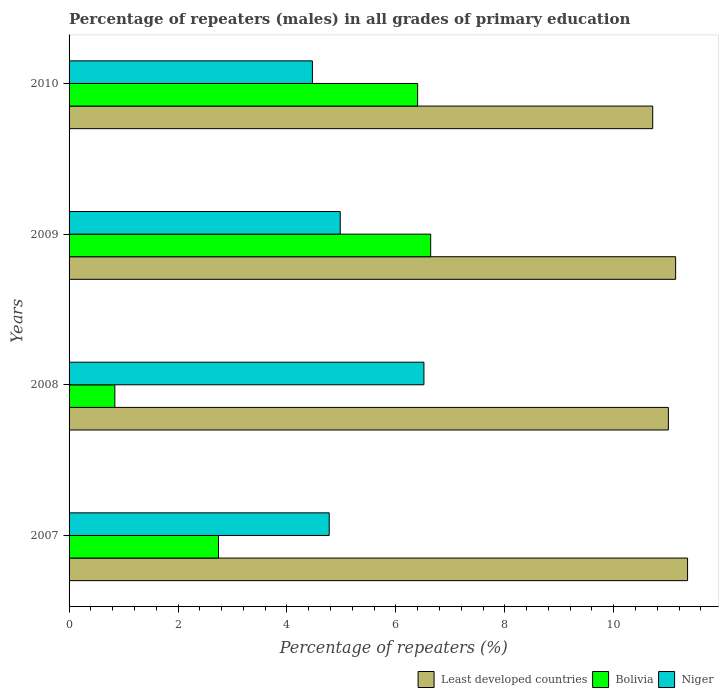How many different coloured bars are there?
Give a very brief answer. 3. How many groups of bars are there?
Provide a short and direct response. 4. How many bars are there on the 4th tick from the bottom?
Offer a very short reply. 3. What is the label of the 2nd group of bars from the top?
Provide a short and direct response. 2009. In how many cases, is the number of bars for a given year not equal to the number of legend labels?
Your answer should be very brief. 0. What is the percentage of repeaters (males) in Bolivia in 2008?
Your answer should be very brief. 0.84. Across all years, what is the maximum percentage of repeaters (males) in Niger?
Provide a short and direct response. 6.51. Across all years, what is the minimum percentage of repeaters (males) in Least developed countries?
Provide a short and direct response. 10.72. In which year was the percentage of repeaters (males) in Bolivia maximum?
Provide a short and direct response. 2009. In which year was the percentage of repeaters (males) in Bolivia minimum?
Your response must be concise. 2008. What is the total percentage of repeaters (males) in Least developed countries in the graph?
Offer a terse response. 44.21. What is the difference between the percentage of repeaters (males) in Bolivia in 2009 and that in 2010?
Offer a very short reply. 0.24. What is the difference between the percentage of repeaters (males) in Bolivia in 2010 and the percentage of repeaters (males) in Least developed countries in 2009?
Give a very brief answer. -4.74. What is the average percentage of repeaters (males) in Bolivia per year?
Give a very brief answer. 4.16. In the year 2010, what is the difference between the percentage of repeaters (males) in Least developed countries and percentage of repeaters (males) in Niger?
Offer a terse response. 6.25. What is the ratio of the percentage of repeaters (males) in Least developed countries in 2007 to that in 2008?
Your answer should be very brief. 1.03. Is the difference between the percentage of repeaters (males) in Least developed countries in 2009 and 2010 greater than the difference between the percentage of repeaters (males) in Niger in 2009 and 2010?
Keep it short and to the point. No. What is the difference between the highest and the second highest percentage of repeaters (males) in Bolivia?
Keep it short and to the point. 0.24. What is the difference between the highest and the lowest percentage of repeaters (males) in Least developed countries?
Offer a very short reply. 0.64. In how many years, is the percentage of repeaters (males) in Niger greater than the average percentage of repeaters (males) in Niger taken over all years?
Offer a terse response. 1. What does the 1st bar from the top in 2010 represents?
Your answer should be compact. Niger. What does the 1st bar from the bottom in 2007 represents?
Your response must be concise. Least developed countries. Is it the case that in every year, the sum of the percentage of repeaters (males) in Niger and percentage of repeaters (males) in Least developed countries is greater than the percentage of repeaters (males) in Bolivia?
Give a very brief answer. Yes. Are all the bars in the graph horizontal?
Provide a succinct answer. Yes. What is the difference between two consecutive major ticks on the X-axis?
Provide a succinct answer. 2. Where does the legend appear in the graph?
Your answer should be very brief. Bottom right. What is the title of the graph?
Keep it short and to the point. Percentage of repeaters (males) in all grades of primary education. Does "Middle East & North Africa (developing only)" appear as one of the legend labels in the graph?
Offer a very short reply. No. What is the label or title of the X-axis?
Make the answer very short. Percentage of repeaters (%). What is the label or title of the Y-axis?
Give a very brief answer. Years. What is the Percentage of repeaters (%) of Least developed countries in 2007?
Provide a short and direct response. 11.36. What is the Percentage of repeaters (%) in Bolivia in 2007?
Provide a succinct answer. 2.74. What is the Percentage of repeaters (%) in Niger in 2007?
Ensure brevity in your answer.  4.78. What is the Percentage of repeaters (%) in Least developed countries in 2008?
Give a very brief answer. 11. What is the Percentage of repeaters (%) in Bolivia in 2008?
Your answer should be compact. 0.84. What is the Percentage of repeaters (%) in Niger in 2008?
Keep it short and to the point. 6.51. What is the Percentage of repeaters (%) of Least developed countries in 2009?
Provide a succinct answer. 11.14. What is the Percentage of repeaters (%) of Bolivia in 2009?
Offer a terse response. 6.64. What is the Percentage of repeaters (%) in Niger in 2009?
Your answer should be very brief. 4.98. What is the Percentage of repeaters (%) in Least developed countries in 2010?
Your answer should be compact. 10.72. What is the Percentage of repeaters (%) in Bolivia in 2010?
Your response must be concise. 6.4. What is the Percentage of repeaters (%) in Niger in 2010?
Keep it short and to the point. 4.47. Across all years, what is the maximum Percentage of repeaters (%) of Least developed countries?
Your answer should be very brief. 11.36. Across all years, what is the maximum Percentage of repeaters (%) in Bolivia?
Your response must be concise. 6.64. Across all years, what is the maximum Percentage of repeaters (%) of Niger?
Keep it short and to the point. 6.51. Across all years, what is the minimum Percentage of repeaters (%) in Least developed countries?
Keep it short and to the point. 10.72. Across all years, what is the minimum Percentage of repeaters (%) in Bolivia?
Your answer should be very brief. 0.84. Across all years, what is the minimum Percentage of repeaters (%) of Niger?
Provide a succinct answer. 4.47. What is the total Percentage of repeaters (%) in Least developed countries in the graph?
Make the answer very short. 44.21. What is the total Percentage of repeaters (%) in Bolivia in the graph?
Offer a very short reply. 16.62. What is the total Percentage of repeaters (%) in Niger in the graph?
Your answer should be compact. 20.74. What is the difference between the Percentage of repeaters (%) in Least developed countries in 2007 and that in 2008?
Give a very brief answer. 0.35. What is the difference between the Percentage of repeaters (%) in Bolivia in 2007 and that in 2008?
Provide a short and direct response. 1.9. What is the difference between the Percentage of repeaters (%) in Niger in 2007 and that in 2008?
Keep it short and to the point. -1.74. What is the difference between the Percentage of repeaters (%) in Least developed countries in 2007 and that in 2009?
Make the answer very short. 0.22. What is the difference between the Percentage of repeaters (%) of Bolivia in 2007 and that in 2009?
Provide a short and direct response. -3.9. What is the difference between the Percentage of repeaters (%) of Niger in 2007 and that in 2009?
Give a very brief answer. -0.2. What is the difference between the Percentage of repeaters (%) in Least developed countries in 2007 and that in 2010?
Your answer should be compact. 0.64. What is the difference between the Percentage of repeaters (%) in Bolivia in 2007 and that in 2010?
Your response must be concise. -3.66. What is the difference between the Percentage of repeaters (%) of Niger in 2007 and that in 2010?
Ensure brevity in your answer.  0.31. What is the difference between the Percentage of repeaters (%) of Least developed countries in 2008 and that in 2009?
Provide a succinct answer. -0.13. What is the difference between the Percentage of repeaters (%) in Bolivia in 2008 and that in 2009?
Keep it short and to the point. -5.8. What is the difference between the Percentage of repeaters (%) of Niger in 2008 and that in 2009?
Make the answer very short. 1.54. What is the difference between the Percentage of repeaters (%) of Least developed countries in 2008 and that in 2010?
Make the answer very short. 0.29. What is the difference between the Percentage of repeaters (%) in Bolivia in 2008 and that in 2010?
Offer a very short reply. -5.56. What is the difference between the Percentage of repeaters (%) of Niger in 2008 and that in 2010?
Ensure brevity in your answer.  2.05. What is the difference between the Percentage of repeaters (%) in Least developed countries in 2009 and that in 2010?
Make the answer very short. 0.42. What is the difference between the Percentage of repeaters (%) in Bolivia in 2009 and that in 2010?
Make the answer very short. 0.24. What is the difference between the Percentage of repeaters (%) of Niger in 2009 and that in 2010?
Provide a short and direct response. 0.51. What is the difference between the Percentage of repeaters (%) in Least developed countries in 2007 and the Percentage of repeaters (%) in Bolivia in 2008?
Keep it short and to the point. 10.51. What is the difference between the Percentage of repeaters (%) of Least developed countries in 2007 and the Percentage of repeaters (%) of Niger in 2008?
Your answer should be compact. 4.84. What is the difference between the Percentage of repeaters (%) in Bolivia in 2007 and the Percentage of repeaters (%) in Niger in 2008?
Ensure brevity in your answer.  -3.77. What is the difference between the Percentage of repeaters (%) of Least developed countries in 2007 and the Percentage of repeaters (%) of Bolivia in 2009?
Make the answer very short. 4.72. What is the difference between the Percentage of repeaters (%) in Least developed countries in 2007 and the Percentage of repeaters (%) in Niger in 2009?
Ensure brevity in your answer.  6.38. What is the difference between the Percentage of repeaters (%) of Bolivia in 2007 and the Percentage of repeaters (%) of Niger in 2009?
Provide a succinct answer. -2.23. What is the difference between the Percentage of repeaters (%) in Least developed countries in 2007 and the Percentage of repeaters (%) in Bolivia in 2010?
Offer a very short reply. 4.96. What is the difference between the Percentage of repeaters (%) of Least developed countries in 2007 and the Percentage of repeaters (%) of Niger in 2010?
Make the answer very short. 6.89. What is the difference between the Percentage of repeaters (%) in Bolivia in 2007 and the Percentage of repeaters (%) in Niger in 2010?
Provide a succinct answer. -1.72. What is the difference between the Percentage of repeaters (%) of Least developed countries in 2008 and the Percentage of repeaters (%) of Bolivia in 2009?
Your answer should be compact. 4.36. What is the difference between the Percentage of repeaters (%) in Least developed countries in 2008 and the Percentage of repeaters (%) in Niger in 2009?
Your response must be concise. 6.02. What is the difference between the Percentage of repeaters (%) of Bolivia in 2008 and the Percentage of repeaters (%) of Niger in 2009?
Your answer should be compact. -4.14. What is the difference between the Percentage of repeaters (%) in Least developed countries in 2008 and the Percentage of repeaters (%) in Bolivia in 2010?
Offer a very short reply. 4.6. What is the difference between the Percentage of repeaters (%) in Least developed countries in 2008 and the Percentage of repeaters (%) in Niger in 2010?
Your answer should be compact. 6.54. What is the difference between the Percentage of repeaters (%) of Bolivia in 2008 and the Percentage of repeaters (%) of Niger in 2010?
Keep it short and to the point. -3.63. What is the difference between the Percentage of repeaters (%) in Least developed countries in 2009 and the Percentage of repeaters (%) in Bolivia in 2010?
Your response must be concise. 4.74. What is the difference between the Percentage of repeaters (%) in Least developed countries in 2009 and the Percentage of repeaters (%) in Niger in 2010?
Keep it short and to the point. 6.67. What is the difference between the Percentage of repeaters (%) of Bolivia in 2009 and the Percentage of repeaters (%) of Niger in 2010?
Your response must be concise. 2.17. What is the average Percentage of repeaters (%) in Least developed countries per year?
Your answer should be very brief. 11.05. What is the average Percentage of repeaters (%) of Bolivia per year?
Your answer should be very brief. 4.16. What is the average Percentage of repeaters (%) of Niger per year?
Offer a very short reply. 5.18. In the year 2007, what is the difference between the Percentage of repeaters (%) in Least developed countries and Percentage of repeaters (%) in Bolivia?
Make the answer very short. 8.61. In the year 2007, what is the difference between the Percentage of repeaters (%) in Least developed countries and Percentage of repeaters (%) in Niger?
Keep it short and to the point. 6.58. In the year 2007, what is the difference between the Percentage of repeaters (%) in Bolivia and Percentage of repeaters (%) in Niger?
Your response must be concise. -2.03. In the year 2008, what is the difference between the Percentage of repeaters (%) of Least developed countries and Percentage of repeaters (%) of Bolivia?
Your response must be concise. 10.16. In the year 2008, what is the difference between the Percentage of repeaters (%) of Least developed countries and Percentage of repeaters (%) of Niger?
Provide a succinct answer. 4.49. In the year 2008, what is the difference between the Percentage of repeaters (%) in Bolivia and Percentage of repeaters (%) in Niger?
Your response must be concise. -5.67. In the year 2009, what is the difference between the Percentage of repeaters (%) in Least developed countries and Percentage of repeaters (%) in Bolivia?
Your response must be concise. 4.5. In the year 2009, what is the difference between the Percentage of repeaters (%) of Least developed countries and Percentage of repeaters (%) of Niger?
Make the answer very short. 6.16. In the year 2009, what is the difference between the Percentage of repeaters (%) of Bolivia and Percentage of repeaters (%) of Niger?
Your response must be concise. 1.66. In the year 2010, what is the difference between the Percentage of repeaters (%) in Least developed countries and Percentage of repeaters (%) in Bolivia?
Offer a terse response. 4.32. In the year 2010, what is the difference between the Percentage of repeaters (%) in Least developed countries and Percentage of repeaters (%) in Niger?
Your answer should be very brief. 6.25. In the year 2010, what is the difference between the Percentage of repeaters (%) in Bolivia and Percentage of repeaters (%) in Niger?
Offer a terse response. 1.93. What is the ratio of the Percentage of repeaters (%) in Least developed countries in 2007 to that in 2008?
Make the answer very short. 1.03. What is the ratio of the Percentage of repeaters (%) in Bolivia in 2007 to that in 2008?
Give a very brief answer. 3.26. What is the ratio of the Percentage of repeaters (%) in Niger in 2007 to that in 2008?
Give a very brief answer. 0.73. What is the ratio of the Percentage of repeaters (%) in Least developed countries in 2007 to that in 2009?
Your answer should be very brief. 1.02. What is the ratio of the Percentage of repeaters (%) in Bolivia in 2007 to that in 2009?
Your response must be concise. 0.41. What is the ratio of the Percentage of repeaters (%) in Niger in 2007 to that in 2009?
Provide a succinct answer. 0.96. What is the ratio of the Percentage of repeaters (%) in Least developed countries in 2007 to that in 2010?
Keep it short and to the point. 1.06. What is the ratio of the Percentage of repeaters (%) in Bolivia in 2007 to that in 2010?
Provide a short and direct response. 0.43. What is the ratio of the Percentage of repeaters (%) in Niger in 2007 to that in 2010?
Your answer should be compact. 1.07. What is the ratio of the Percentage of repeaters (%) of Least developed countries in 2008 to that in 2009?
Offer a terse response. 0.99. What is the ratio of the Percentage of repeaters (%) of Bolivia in 2008 to that in 2009?
Keep it short and to the point. 0.13. What is the ratio of the Percentage of repeaters (%) of Niger in 2008 to that in 2009?
Give a very brief answer. 1.31. What is the ratio of the Percentage of repeaters (%) in Least developed countries in 2008 to that in 2010?
Keep it short and to the point. 1.03. What is the ratio of the Percentage of repeaters (%) of Bolivia in 2008 to that in 2010?
Your answer should be compact. 0.13. What is the ratio of the Percentage of repeaters (%) in Niger in 2008 to that in 2010?
Offer a terse response. 1.46. What is the ratio of the Percentage of repeaters (%) of Least developed countries in 2009 to that in 2010?
Your answer should be very brief. 1.04. What is the ratio of the Percentage of repeaters (%) in Bolivia in 2009 to that in 2010?
Your answer should be very brief. 1.04. What is the ratio of the Percentage of repeaters (%) of Niger in 2009 to that in 2010?
Provide a succinct answer. 1.11. What is the difference between the highest and the second highest Percentage of repeaters (%) in Least developed countries?
Provide a short and direct response. 0.22. What is the difference between the highest and the second highest Percentage of repeaters (%) in Bolivia?
Give a very brief answer. 0.24. What is the difference between the highest and the second highest Percentage of repeaters (%) in Niger?
Provide a succinct answer. 1.54. What is the difference between the highest and the lowest Percentage of repeaters (%) in Least developed countries?
Your answer should be compact. 0.64. What is the difference between the highest and the lowest Percentage of repeaters (%) in Bolivia?
Make the answer very short. 5.8. What is the difference between the highest and the lowest Percentage of repeaters (%) in Niger?
Your answer should be compact. 2.05. 